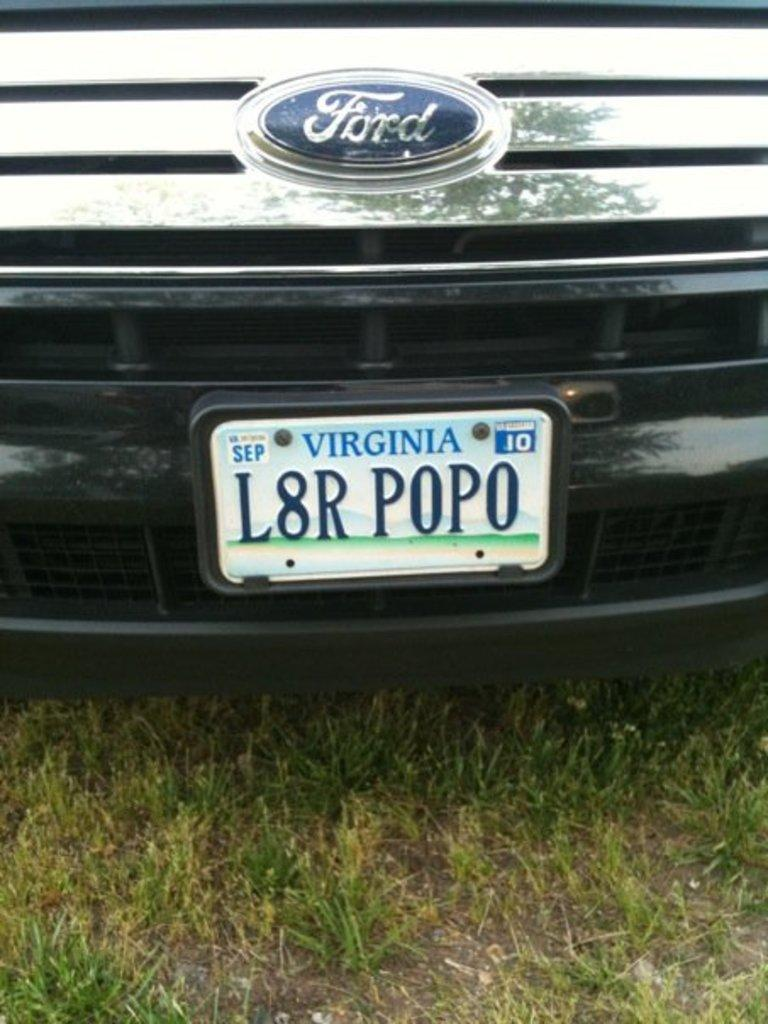<image>
Summarize the visual content of the image. A Ford vehicle from Virginia has the license plate number L8R P0P0. 